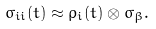Convert formula to latex. <formula><loc_0><loc_0><loc_500><loc_500>\sigma _ { i i } ( t ) \approx \rho _ { i } ( t ) \otimes \sigma _ { \beta } .</formula> 